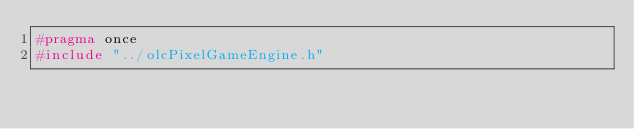<code> <loc_0><loc_0><loc_500><loc_500><_C_>#pragma once
#include "../olcPixelGameEngine.h"</code> 